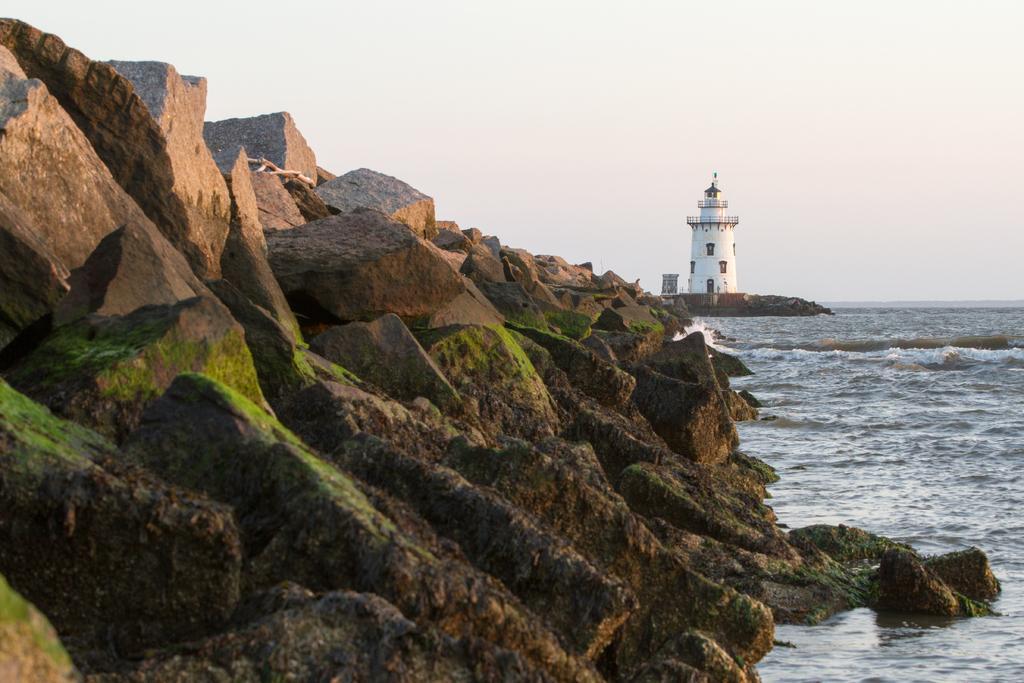Describe this image in one or two sentences. In this image we can see ocean rocks, water and in the background of the image there is light house and clear sky. 